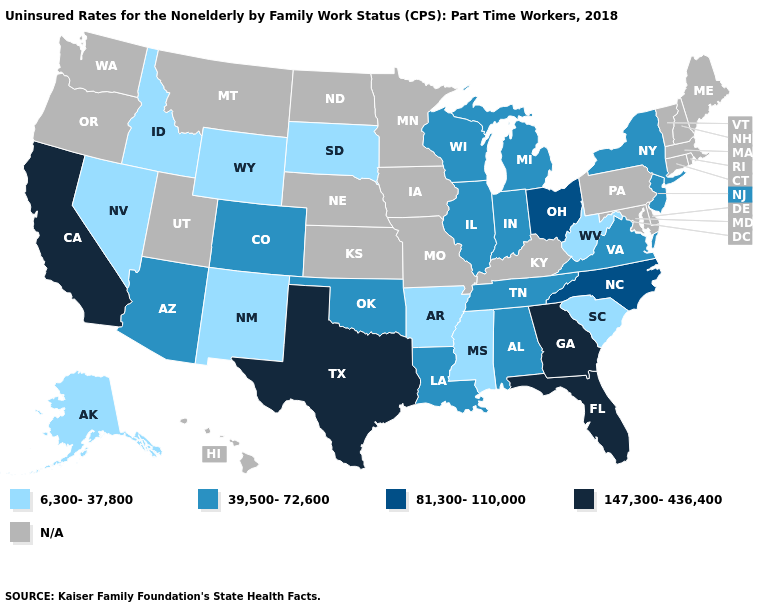What is the value of Minnesota?
Keep it brief. N/A. Among the states that border Wyoming , which have the lowest value?
Give a very brief answer. Idaho, South Dakota. Which states have the highest value in the USA?
Answer briefly. California, Florida, Georgia, Texas. Among the states that border Pennsylvania , does New Jersey have the lowest value?
Short answer required. No. What is the lowest value in the South?
Concise answer only. 6,300-37,800. Among the states that border Louisiana , does Arkansas have the lowest value?
Be succinct. Yes. Name the states that have a value in the range 81,300-110,000?
Short answer required. North Carolina, Ohio. Does Mississippi have the lowest value in the South?
Concise answer only. Yes. Name the states that have a value in the range 147,300-436,400?
Answer briefly. California, Florida, Georgia, Texas. Among the states that border Nevada , does Idaho have the lowest value?
Be succinct. Yes. Does the first symbol in the legend represent the smallest category?
Concise answer only. Yes. Name the states that have a value in the range 81,300-110,000?
Concise answer only. North Carolina, Ohio. What is the value of Hawaii?
Write a very short answer. N/A. Name the states that have a value in the range 39,500-72,600?
Answer briefly. Alabama, Arizona, Colorado, Illinois, Indiana, Louisiana, Michigan, New Jersey, New York, Oklahoma, Tennessee, Virginia, Wisconsin. 